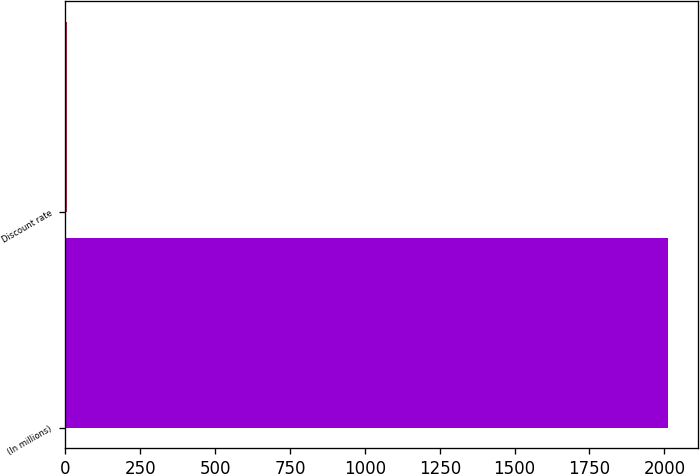Convert chart to OTSL. <chart><loc_0><loc_0><loc_500><loc_500><bar_chart><fcel>(In millions)<fcel>Discount rate<nl><fcel>2011<fcel>5.25<nl></chart> 